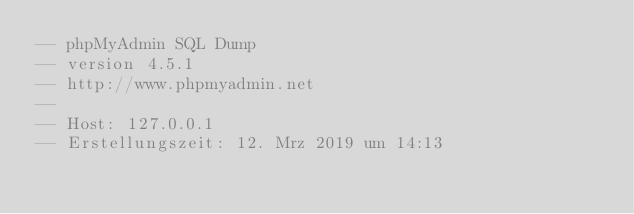Convert code to text. <code><loc_0><loc_0><loc_500><loc_500><_SQL_>-- phpMyAdmin SQL Dump
-- version 4.5.1
-- http://www.phpmyadmin.net
--
-- Host: 127.0.0.1
-- Erstellungszeit: 12. Mrz 2019 um 14:13</code> 